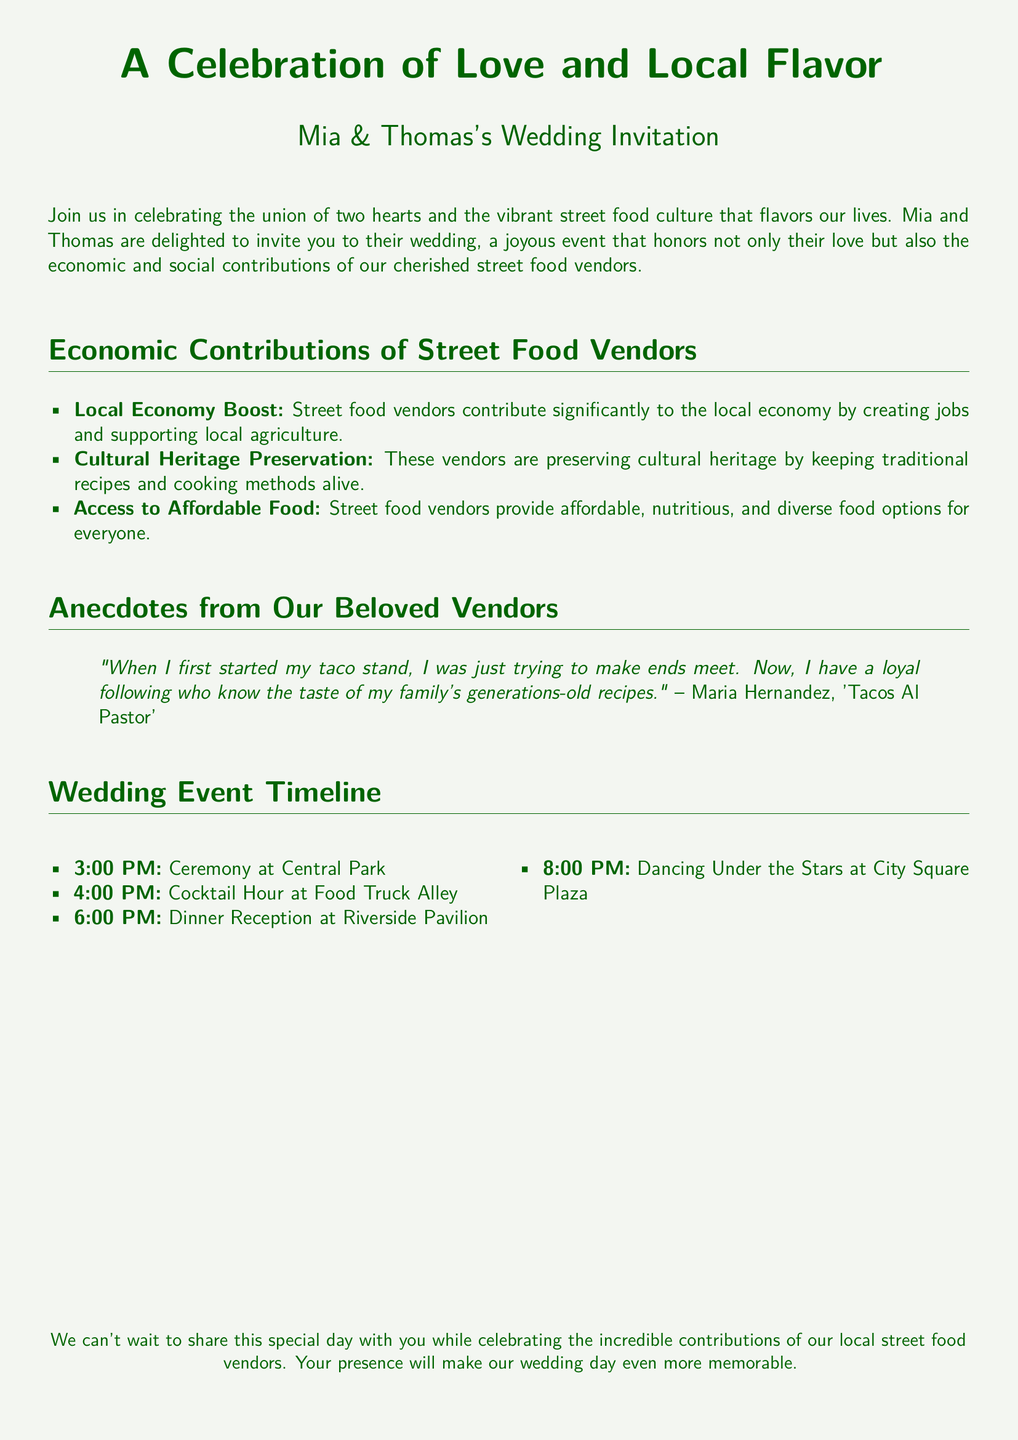What is the title of the wedding invitation? The title is prominently displayed at the top of the document, indicating the event being celebrated.
Answer: A Celebration of Love and Local Flavor Who are the couple getting married? The document introduces the couple early on, stating their names clearly.
Answer: Mia & Thomas What time does the ceremony start? The event timeline lists the starting time of the ceremony, which is specified.
Answer: 3:00 PM What is the name of the vendor quoted in the invitation? The anecdote includes a specific vendor's name who shares their experience, providing personal context.
Answer: Maria Hernandez What is one economic contribution mentioned about street food vendors? The document lists specific contributions and highlights their importance to the community.
Answer: Local Economy Boost Where will the cocktail hour take place? The timeline specifies the location for the cocktail hour, indicating where guests can gather.
Answer: Food Truck Alley What type of cuisine does Maria Hernandez sell? The quote from the vendor mentions her specialty, which reflects her business.
Answer: Tacos Al Pastor What is the location for the dinner reception? The event timeline includes the specific venue for the dinner reception, crucial for guest logistics.
Answer: Riverside Pavilion What event starts at 8:00 PM? The timeline provides an outline of the evening events, indicating what follows dinner.
Answer: Dancing Under the Stars 